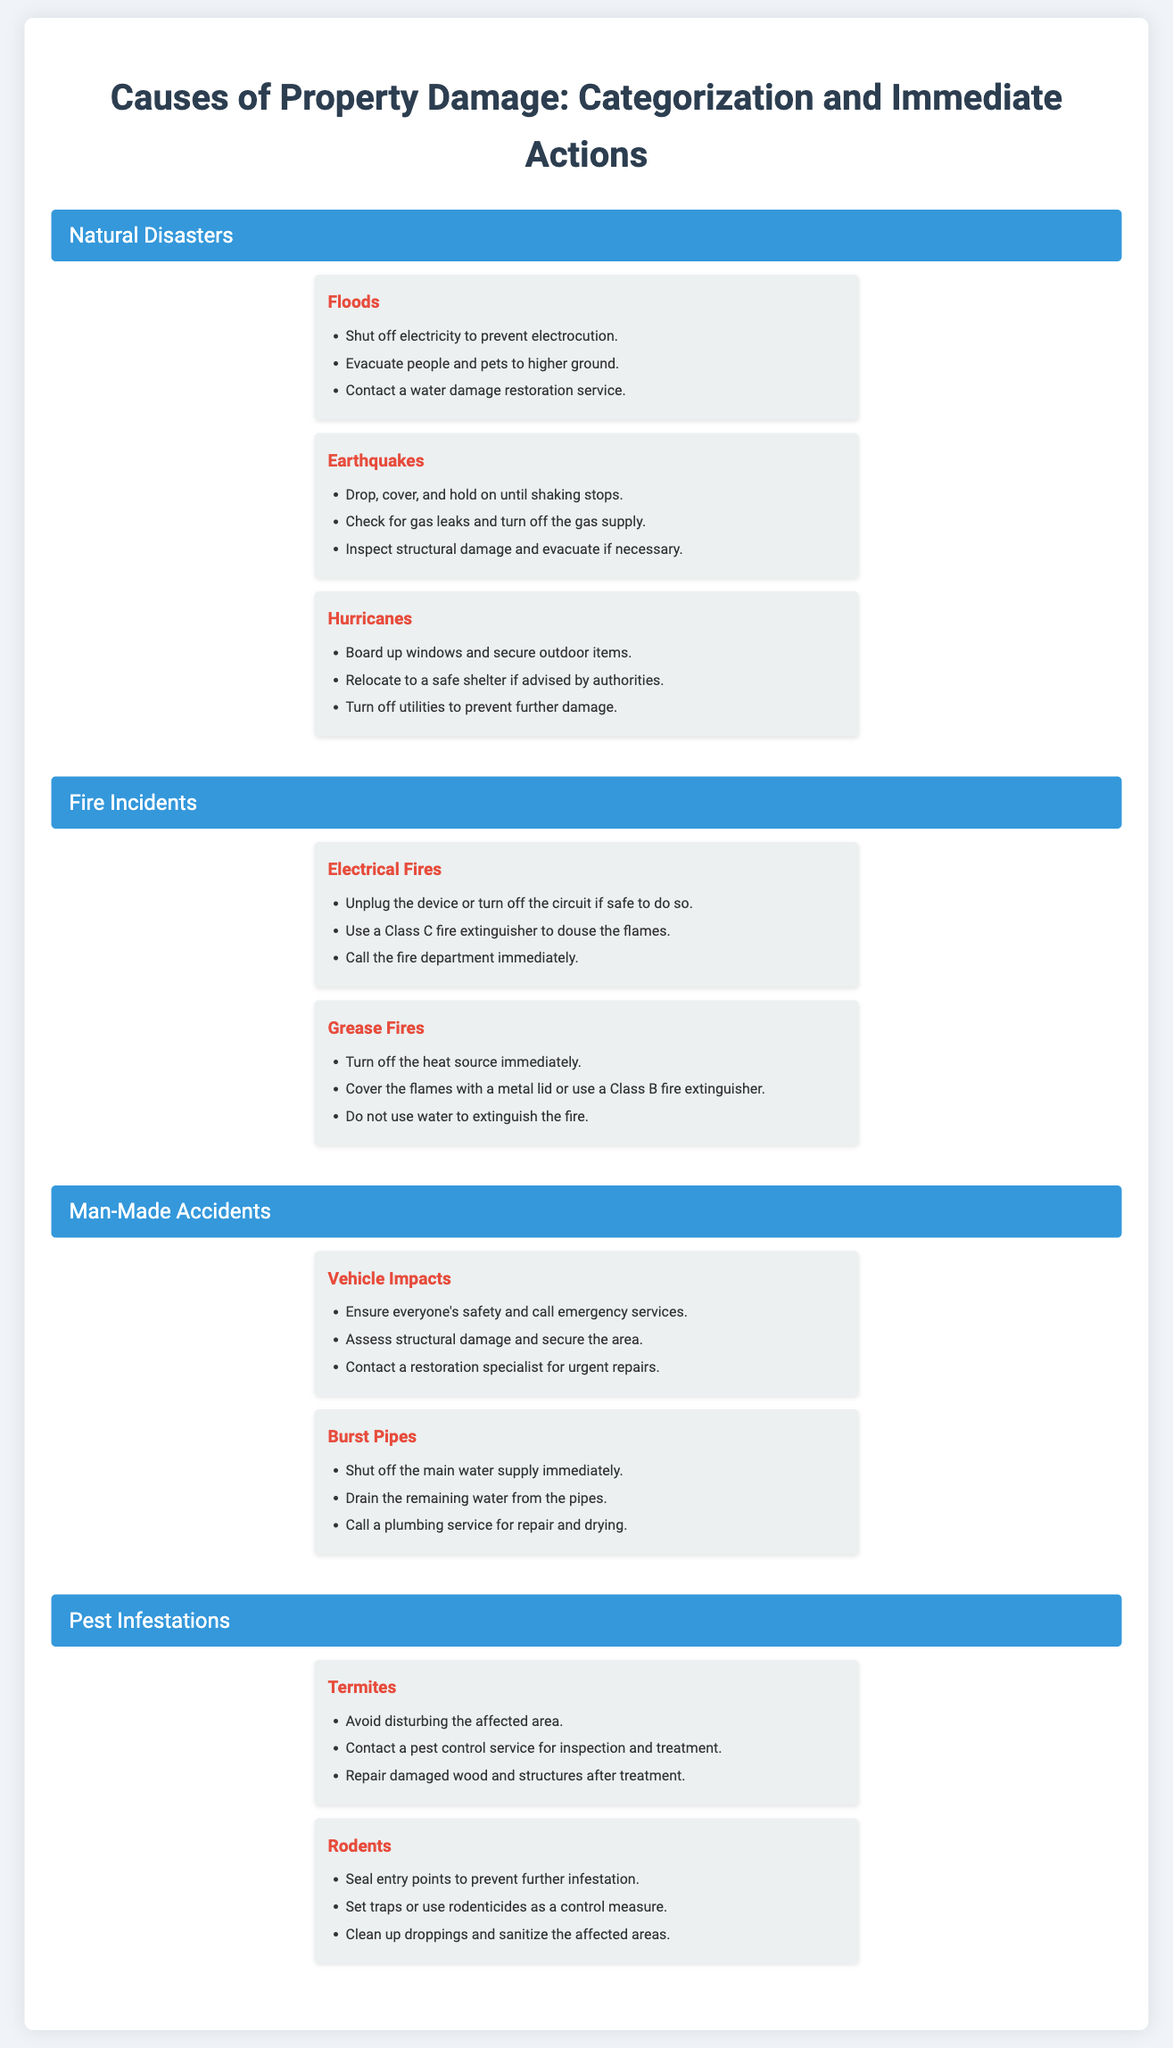What are three types of natural disasters listed? The document includes floods, earthquakes, and hurricanes under natural disasters.
Answer: floods, earthquakes, hurricanes What immediate action should be taken for a flood? The document states that one should shut off electricity to prevent electrocution during a flood.
Answer: Shut off electricity How should you evacuate during a hurricane? The document advises relocating to a safe shelter if advised by authorities during a hurricane.
Answer: Relocate to a safe shelter What type of fire requires a Class C fire extinguisher? The document mentions electrical fires require a Class C fire extinguisher to douse the flames.
Answer: Electrical fires What immediate step should be taken for a burst pipe? The document emphasizes shutting off the main water supply immediately for a burst pipe.
Answer: Shut off the main water supply How can you control a rodent infestation? The document suggests sealing entry points as an effective measure to control rodent infestations.
Answer: Seal entry points What is a crucial action during an earthquake? The document indicates that one should drop, cover, and hold on until shaking stops during an earthquake.
Answer: Drop, cover, and hold on What should you NOT use to extinguish a grease fire? The document clearly states that water should not be used to extinguish a grease fire.
Answer: Water 